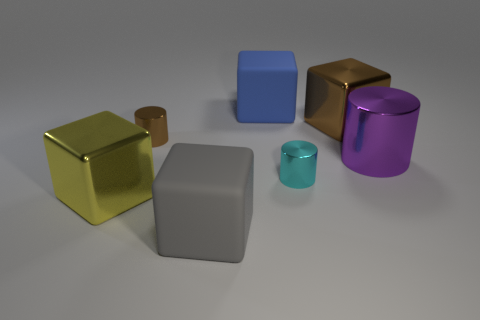What is the material of the cyan cylinder?
Provide a short and direct response. Metal. What shape is the thing that is in front of the yellow object in front of the large purple thing?
Provide a short and direct response. Cube. How many other things are the same shape as the purple metal object?
Provide a succinct answer. 2. Are there any objects in front of the big shiny cylinder?
Provide a short and direct response. Yes. What color is the large cylinder?
Make the answer very short. Purple. Are there any metallic objects of the same size as the blue matte cube?
Provide a succinct answer. Yes. There is a thing left of the brown cylinder; what is it made of?
Offer a terse response. Metal. Are there the same number of yellow blocks that are in front of the yellow shiny block and brown shiny objects in front of the big gray cube?
Offer a very short reply. Yes. Is the size of the rubber thing in front of the big metal cylinder the same as the shiny cylinder behind the purple object?
Keep it short and to the point. No. Is the number of large things in front of the tiny brown shiny object greater than the number of brown metal cylinders?
Provide a short and direct response. Yes. 